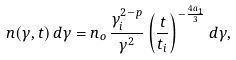Convert formula to latex. <formula><loc_0><loc_0><loc_500><loc_500>n ( \gamma , t ) \, d \gamma = n _ { o } \, \frac { \gamma _ { i } ^ { 2 - p } } { \gamma ^ { 2 } } \left ( \frac { t } { t _ { i } } \right ) ^ { - \frac { 4 a _ { 1 } } { 3 } } d \gamma ,</formula> 